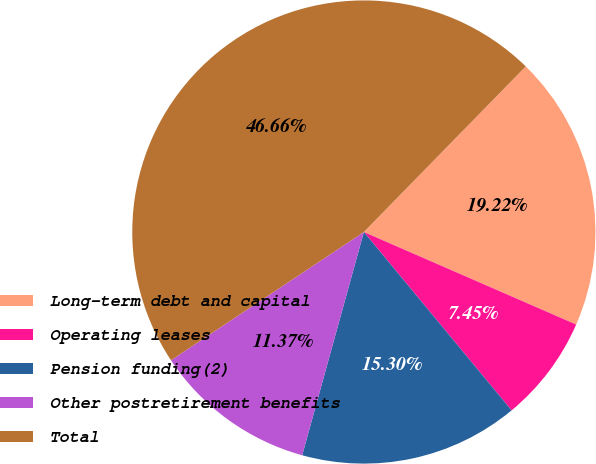Convert chart to OTSL. <chart><loc_0><loc_0><loc_500><loc_500><pie_chart><fcel>Long-term debt and capital<fcel>Operating leases<fcel>Pension funding(2)<fcel>Other postretirement benefits<fcel>Total<nl><fcel>19.22%<fcel>7.45%<fcel>15.3%<fcel>11.37%<fcel>46.66%<nl></chart> 